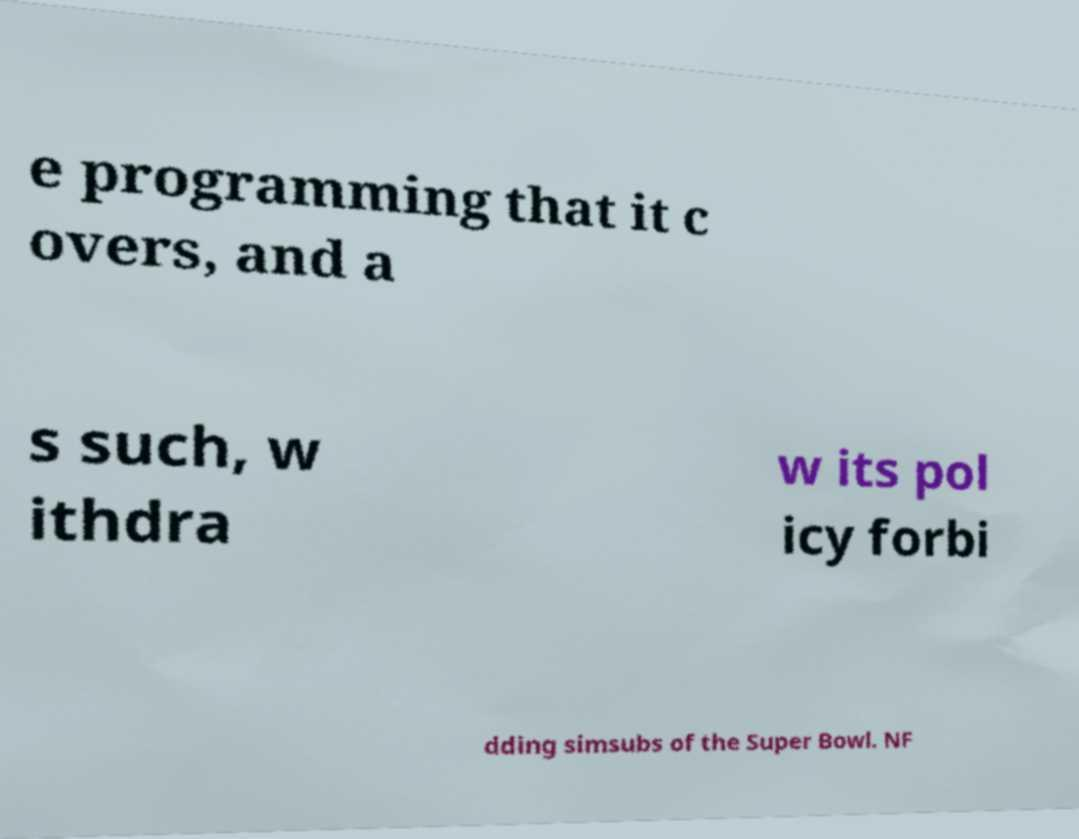Can you accurately transcribe the text from the provided image for me? e programming that it c overs, and a s such, w ithdra w its pol icy forbi dding simsubs of the Super Bowl. NF 